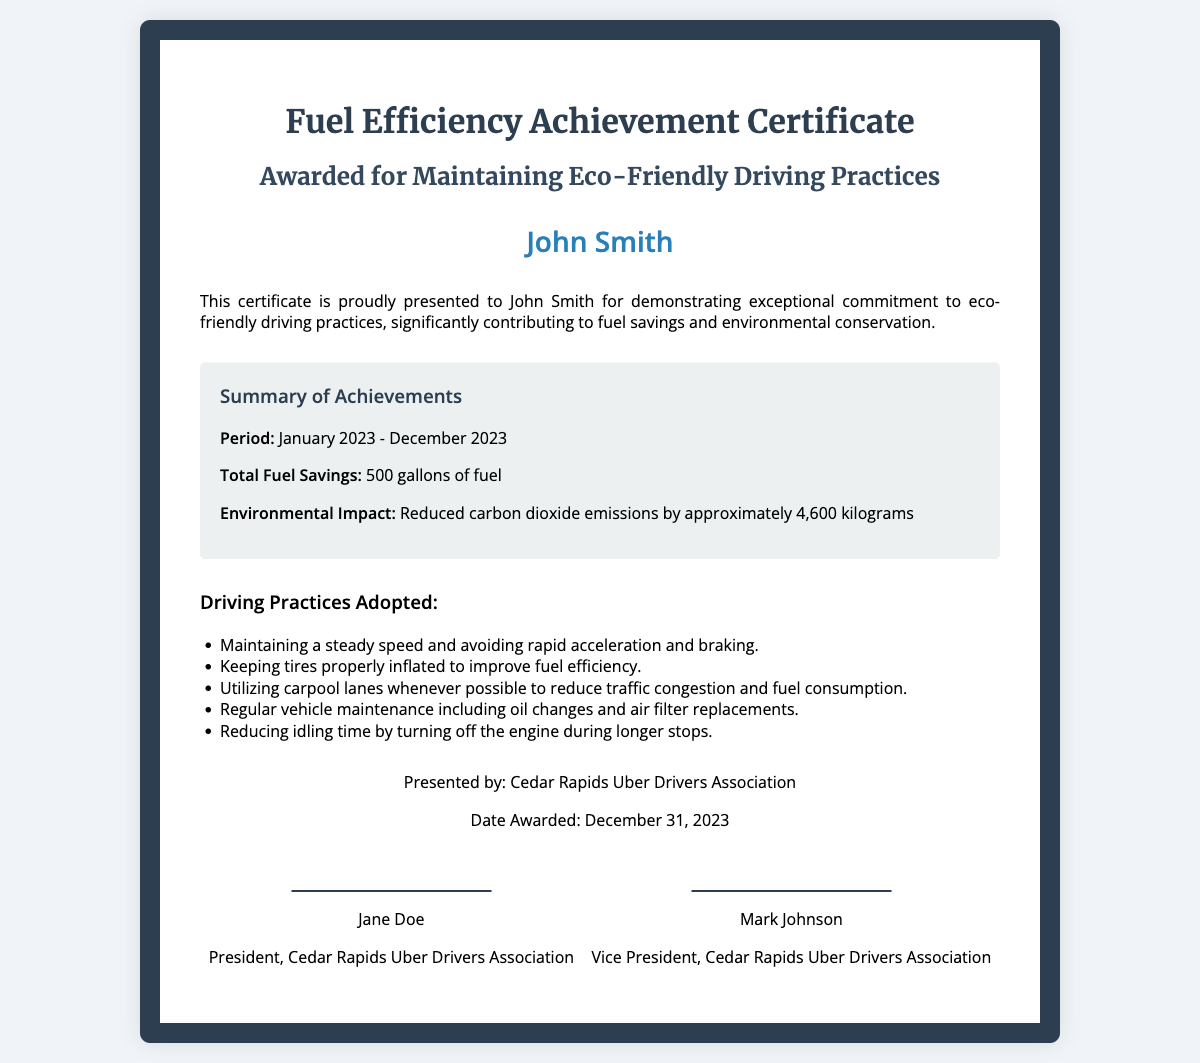What is the period of achievement? The period mentioned in the certificate is from January 2023 to December 2023.
Answer: January 2023 - December 2023 Who is the recipient of the certificate? The certificate is presented to John Smith.
Answer: John Smith What is the total fuel savings? The document states that the total fuel savings achieved is 500 gallons.
Answer: 500 gallons What is the reduced carbon dioxide emissions? The certificate indicates that the reduced carbon dioxide emissions are approximately 4,600 kilograms.
Answer: 4,600 kilograms Which organization presented the certificate? The certificate was presented by the Cedar Rapids Uber Drivers Association.
Answer: Cedar Rapids Uber Drivers Association What driving practice involves tire maintenance? Keeping tires properly inflated to improve fuel efficiency is mentioned in the document as a driving practice.
Answer: Keeping tires properly inflated Who is the president of the Cedar Rapids Uber Drivers Association? The signature line indicates that Jane Doe is the president of the association.
Answer: Jane Doe What date was the award presented? The award was presented on December 31, 2023.
Answer: December 31, 2023 What is one way to reduce idling time? The document suggests turning off the engine during longer stops to reduce idling time.
Answer: Turning off the engine during longer stops 